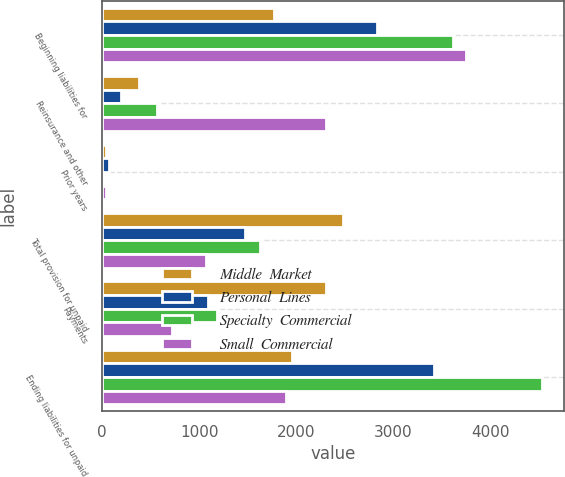<chart> <loc_0><loc_0><loc_500><loc_500><stacked_bar_chart><ecel><fcel>Beginning liabilities for<fcel>Reinsurance and other<fcel>Prior years<fcel>Total provision for unpaid<fcel>Payments<fcel>Ending liabilities for unpaid<nl><fcel>Middle  Market<fcel>1767<fcel>385<fcel>38<fcel>2478<fcel>2309<fcel>1959<nl><fcel>Personal  Lines<fcel>2831<fcel>192<fcel>75<fcel>1468<fcel>1092<fcel>3421<nl><fcel>Specialty  Commercial<fcel>3620<fcel>565<fcel>13<fcel>1626<fcel>1189<fcel>4536<nl><fcel>Small  Commercial<fcel>3754<fcel>2306<fcel>36<fcel>1070<fcel>725<fcel>1892<nl></chart> 